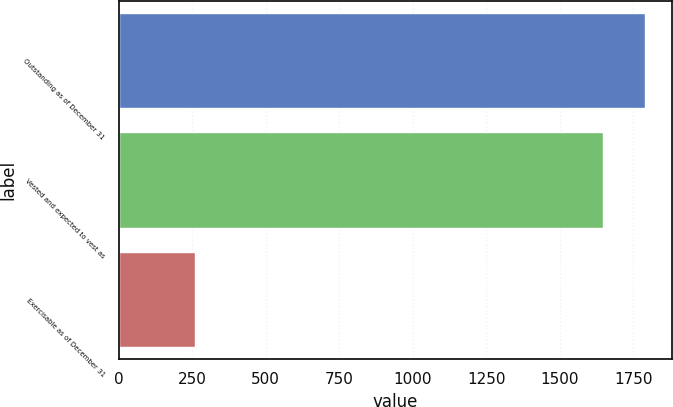Convert chart to OTSL. <chart><loc_0><loc_0><loc_500><loc_500><bar_chart><fcel>Outstanding as of December 31<fcel>Vested and expected to vest as<fcel>Exercisable as of December 31<nl><fcel>1790.2<fcel>1647<fcel>258<nl></chart> 